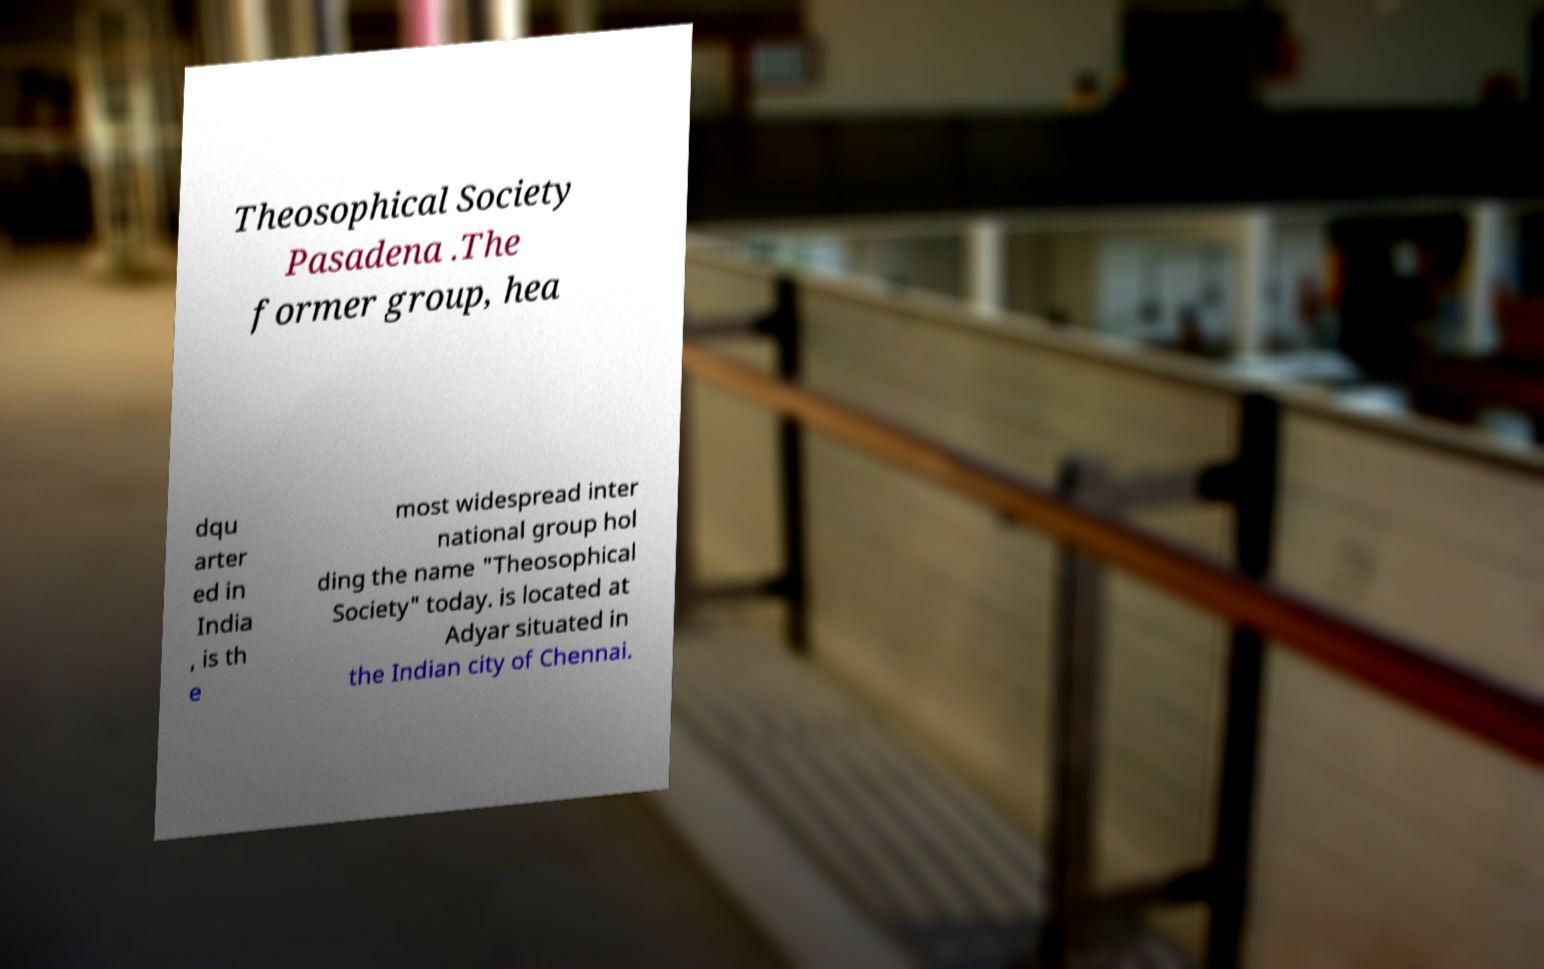There's text embedded in this image that I need extracted. Can you transcribe it verbatim? Theosophical Society Pasadena .The former group, hea dqu arter ed in India , is th e most widespread inter national group hol ding the name "Theosophical Society" today. is located at Adyar situated in the Indian city of Chennai. 